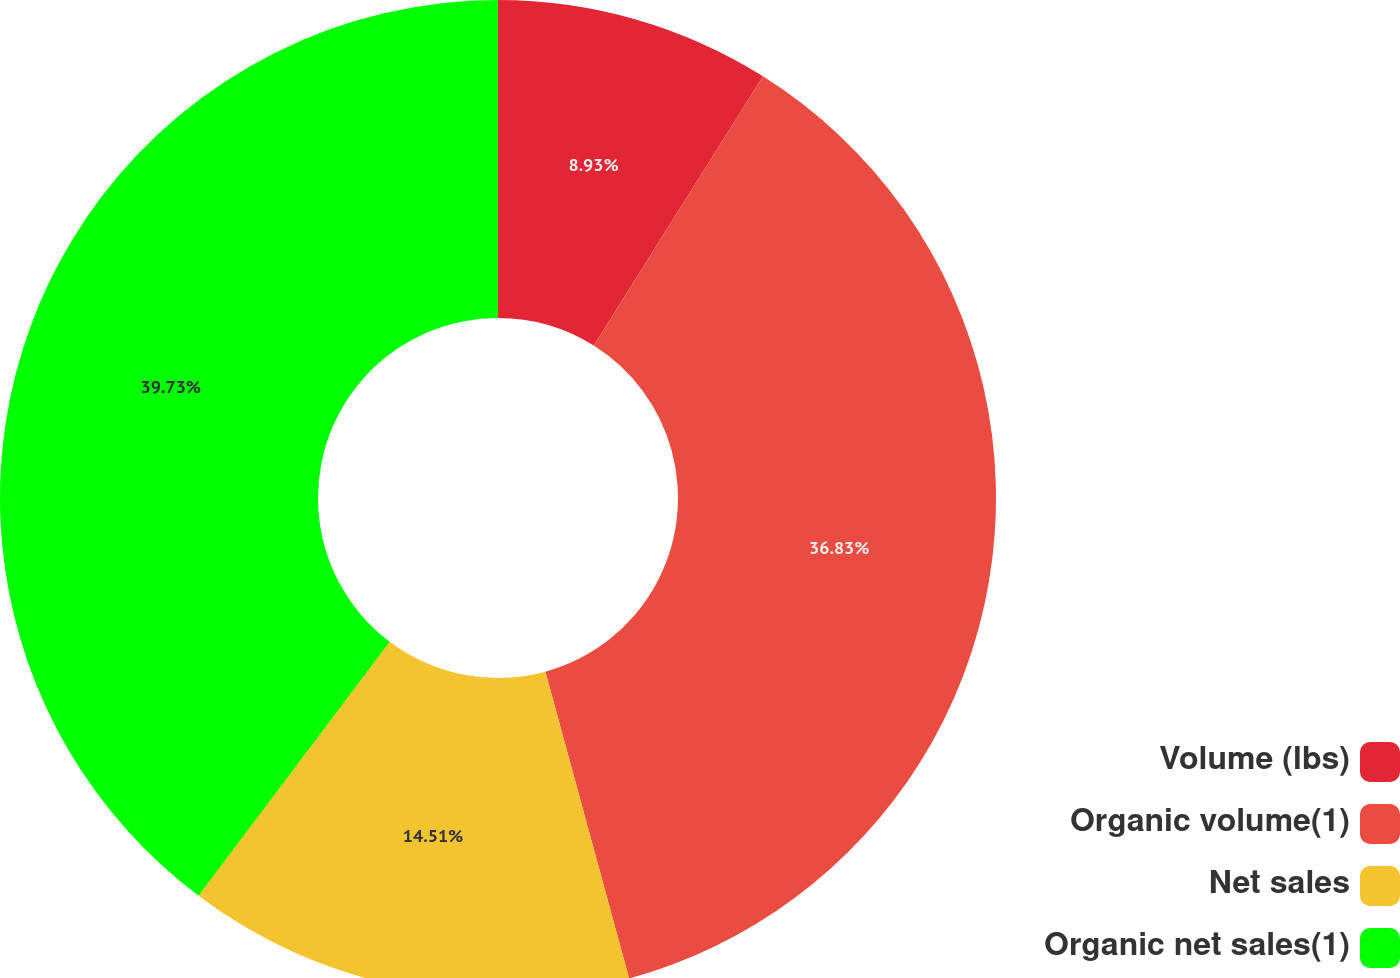Convert chart to OTSL. <chart><loc_0><loc_0><loc_500><loc_500><pie_chart><fcel>Volume (lbs)<fcel>Organic volume(1)<fcel>Net sales<fcel>Organic net sales(1)<nl><fcel>8.93%<fcel>36.83%<fcel>14.51%<fcel>39.73%<nl></chart> 